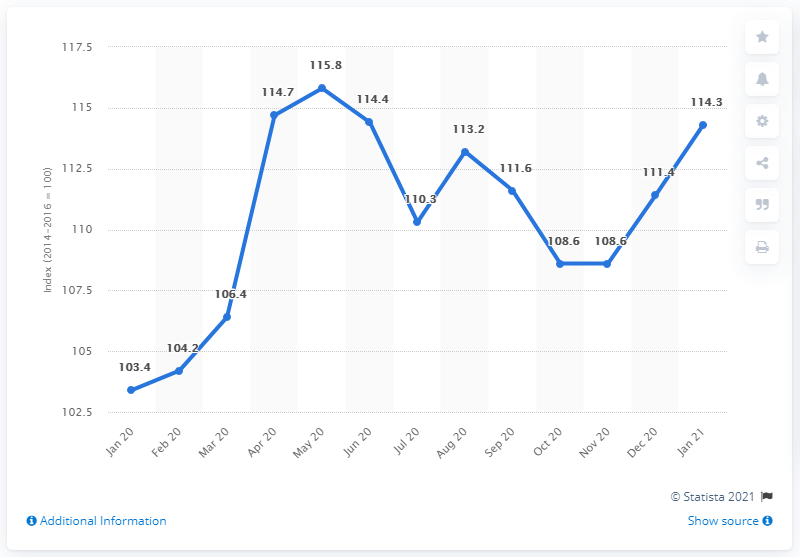Give some essential details in this illustration. The rice price index in April 2020 was 114.7. 